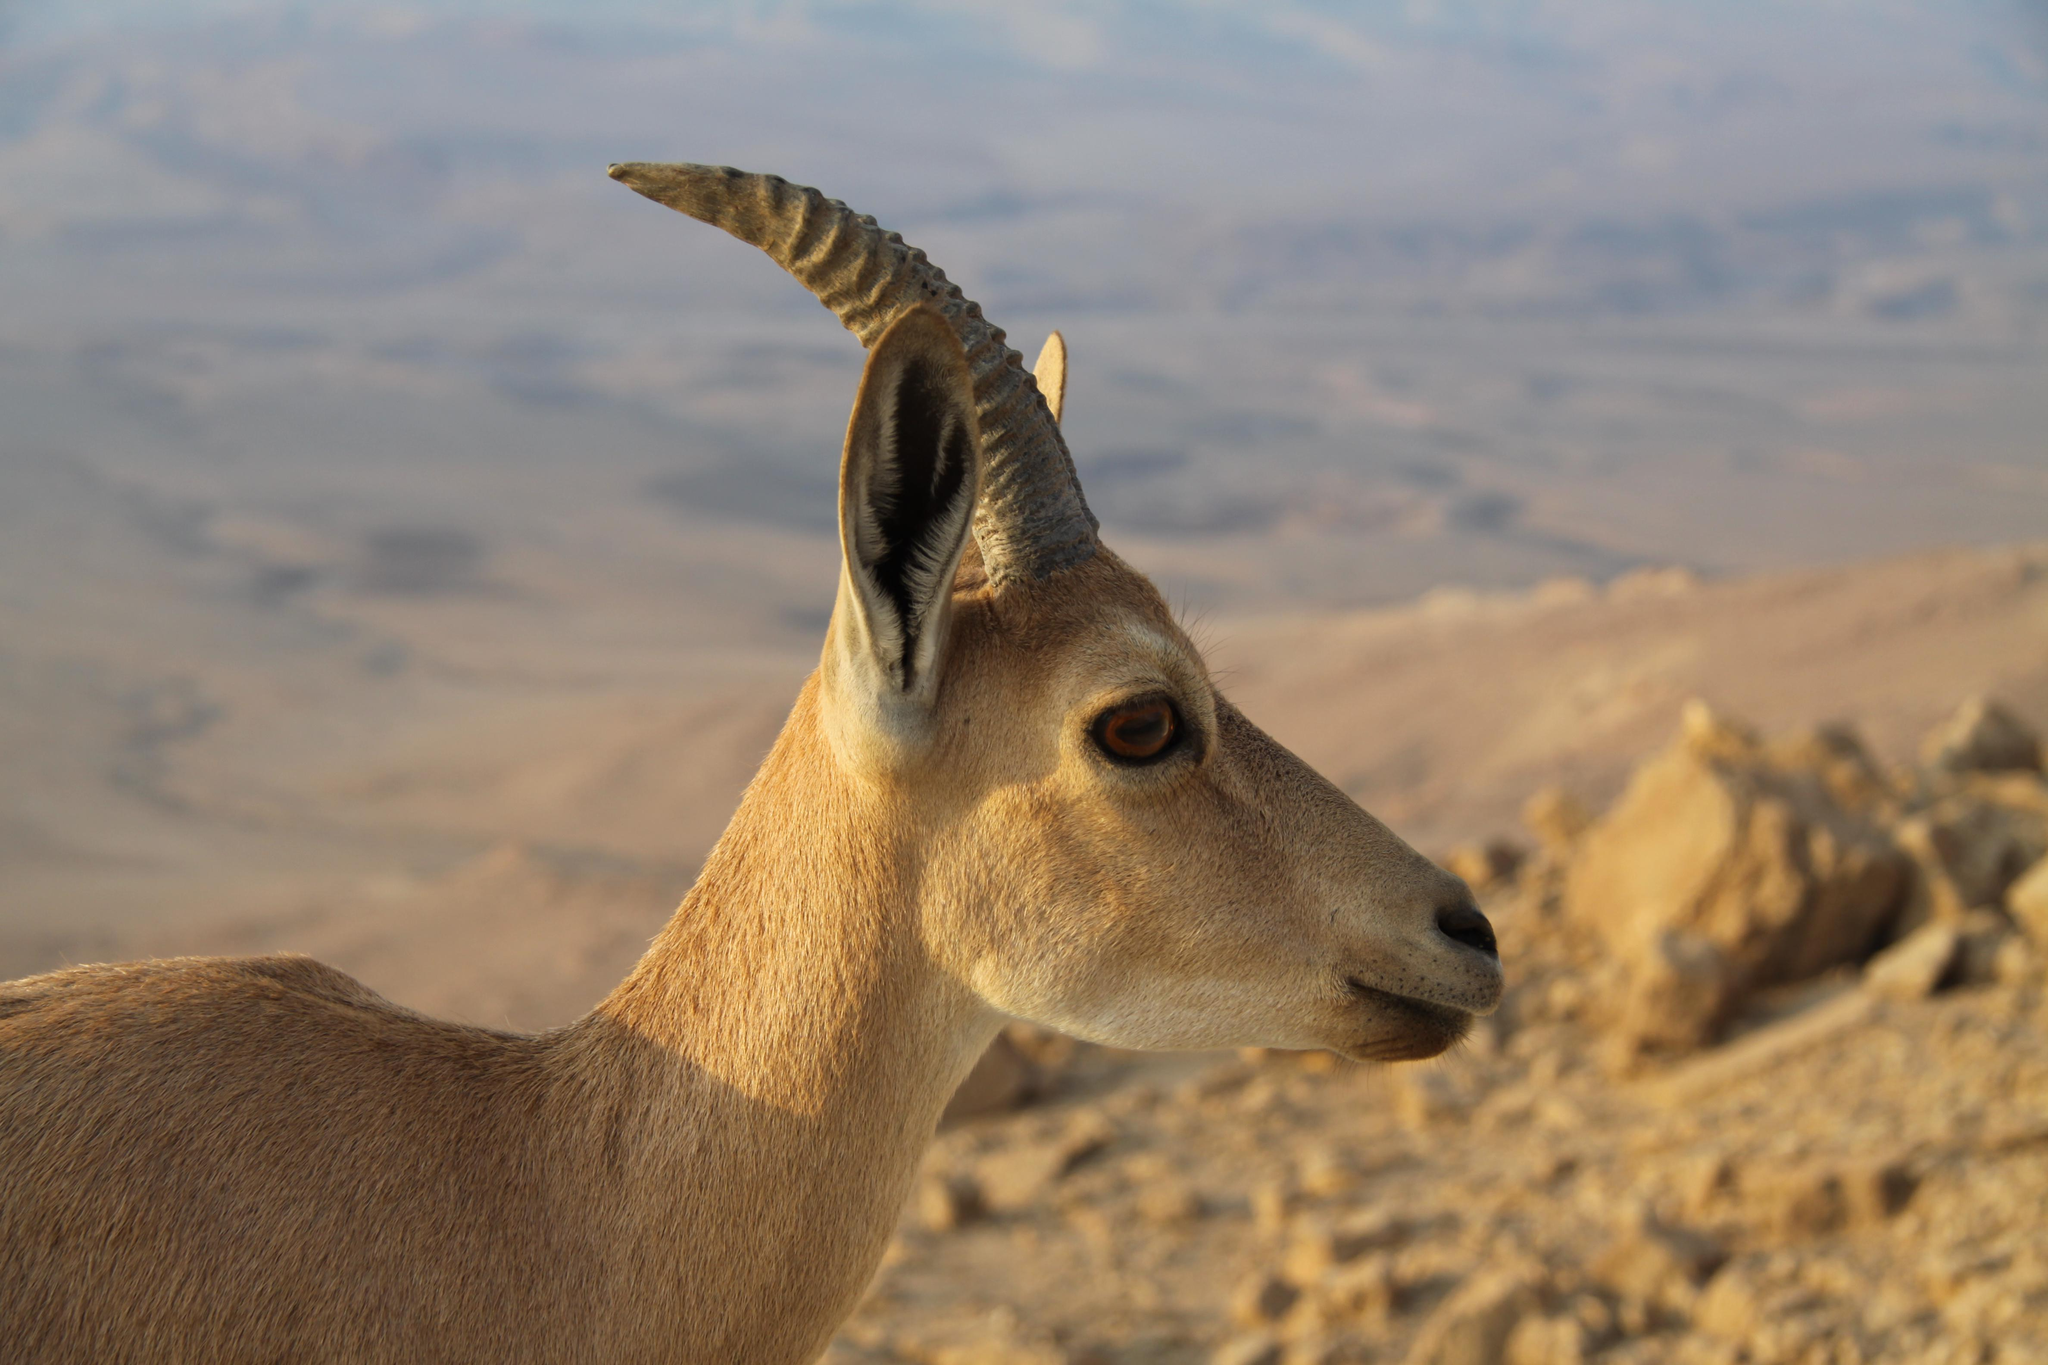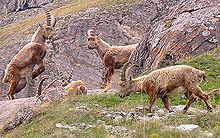The first image is the image on the left, the second image is the image on the right. Considering the images on both sides, is "One image contains more than one animal." valid? Answer yes or no. Yes. The first image is the image on the left, the second image is the image on the right. Analyze the images presented: Is the assertion "There is exactly one animal in the image on the right." valid? Answer yes or no. No. 